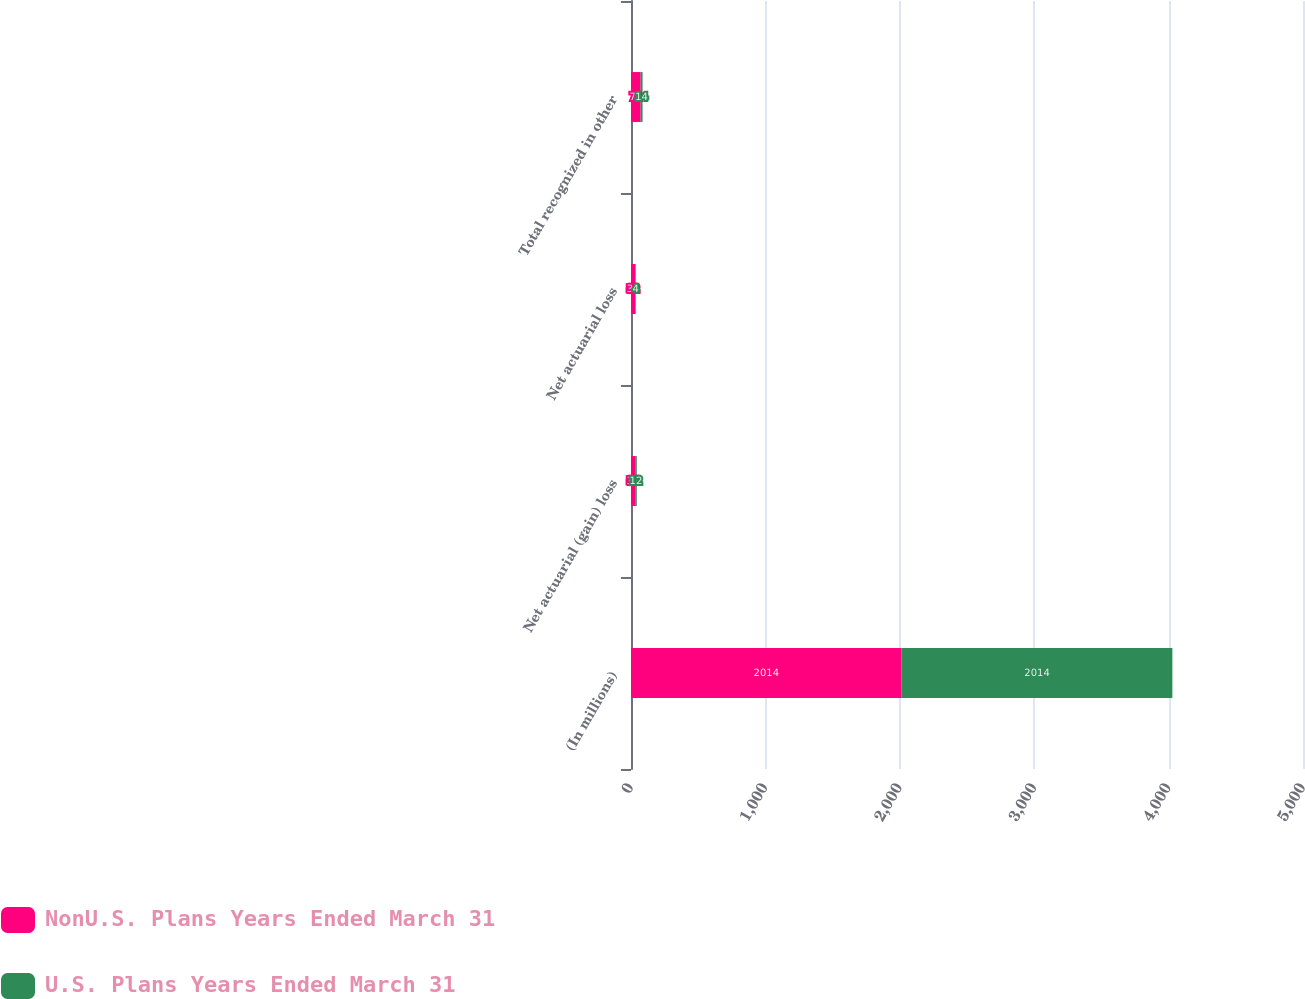Convert chart. <chart><loc_0><loc_0><loc_500><loc_500><stacked_bar_chart><ecel><fcel>(In millions)<fcel>Net actuarial (gain) loss<fcel>Net actuarial loss<fcel>Total recognized in other<nl><fcel>NonU.S. Plans Years Ended March 31<fcel>2014<fcel>31<fcel>32<fcel>72<nl><fcel>U.S. Plans Years Ended March 31<fcel>2014<fcel>12<fcel>4<fcel>14<nl></chart> 